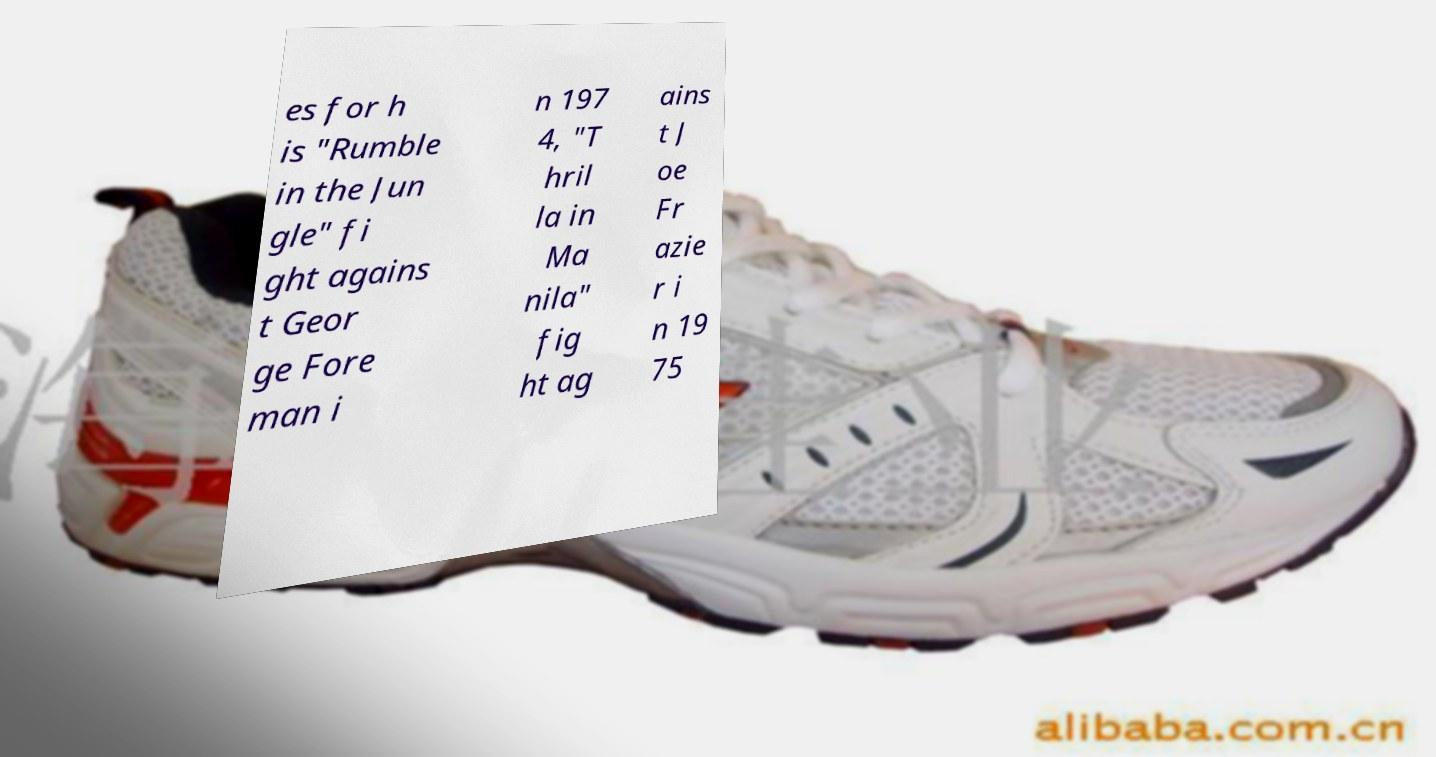Could you extract and type out the text from this image? es for h is "Rumble in the Jun gle" fi ght agains t Geor ge Fore man i n 197 4, "T hril la in Ma nila" fig ht ag ains t J oe Fr azie r i n 19 75 